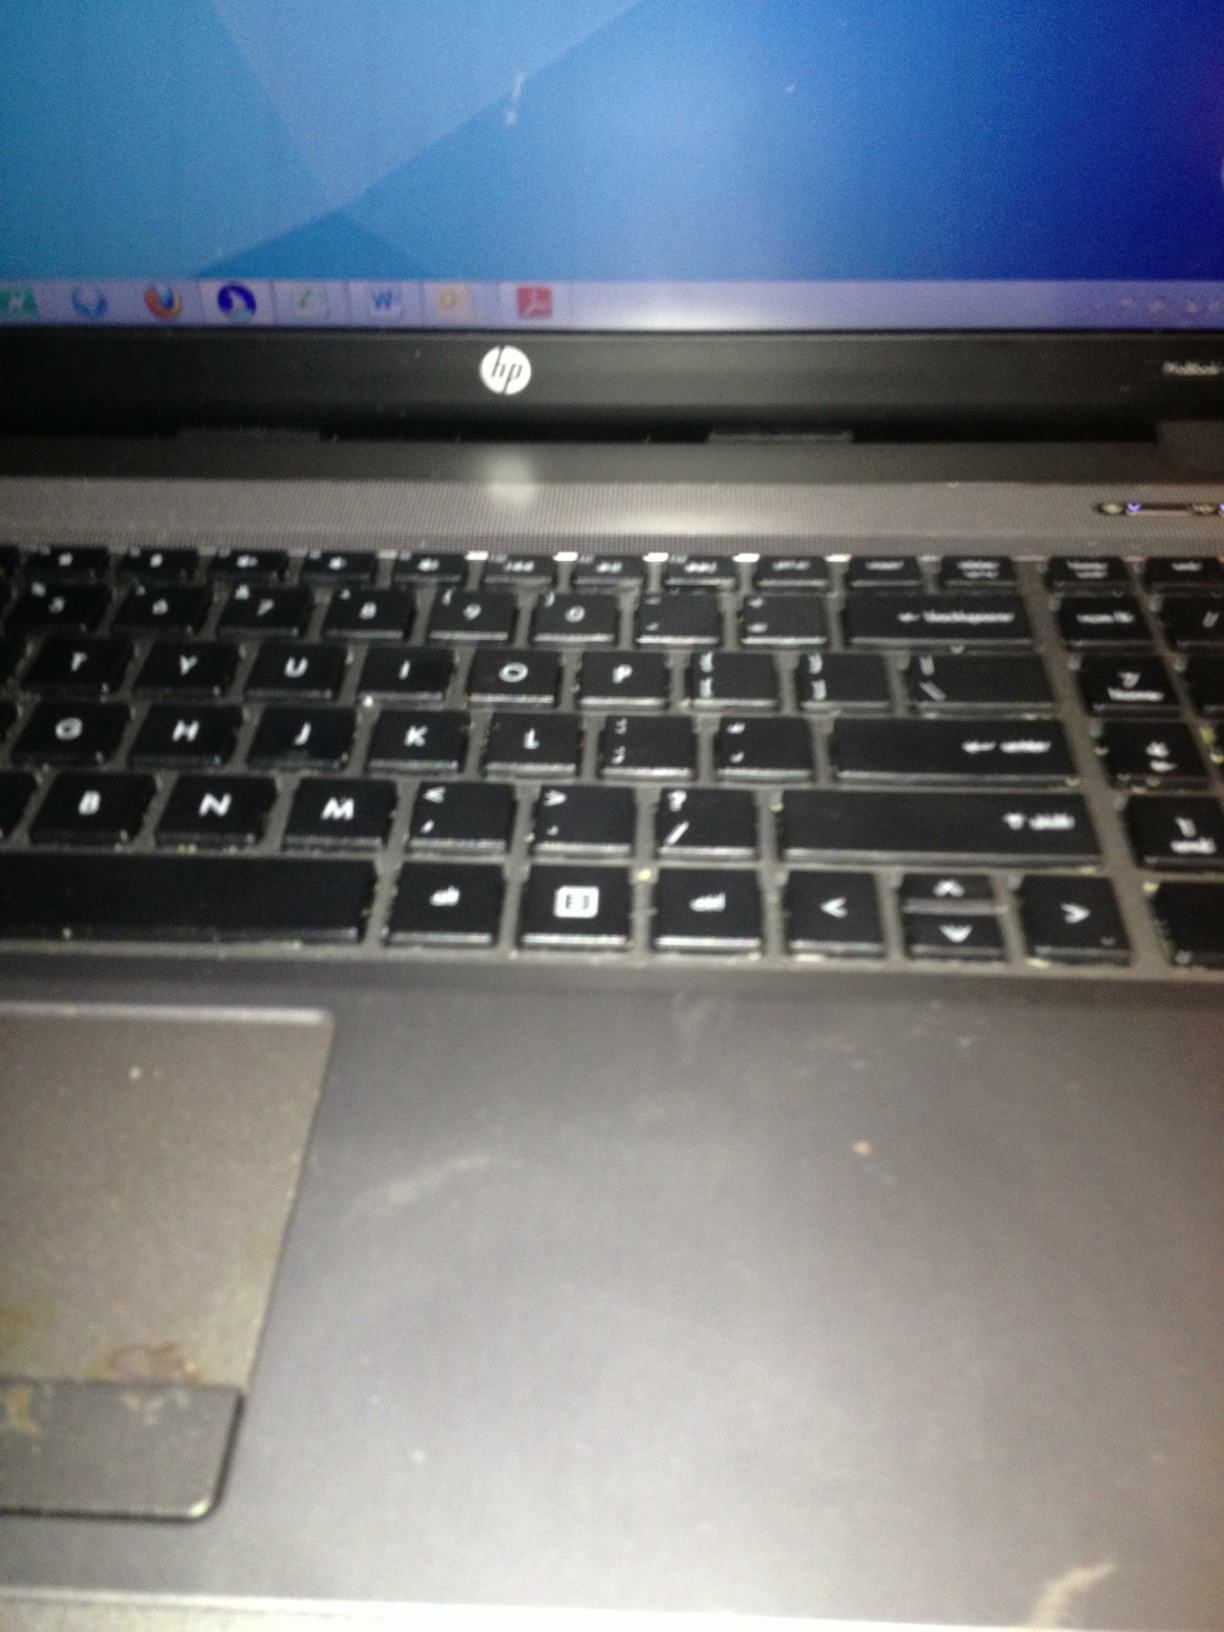If I wanted to use this laptop for gaming, what steps should I take to ensure it performs optimally? For optimal gaming performance on this HP laptop, ensure the following steps: 
1. Clean the laptop to prevent overheating.
2. Update all drivers, especially graphics drivers.
3. Check system requirements for the games you plan to play and adjust settings accordingly.
4. Close unnecessary background applications to maximize available resources.
5. Consider upgrading hardware if possible, such as adding more RAM or an SSD for faster loading times.
6. Invest in a cooling pad to further manage temperature during gaming sessions. 